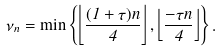<formula> <loc_0><loc_0><loc_500><loc_500>\nu _ { n } = \min \left \{ \left \lfloor \frac { ( 1 + \tau ) n } { 4 } \right \rfloor , \left \lfloor \frac { - \tau n } { 4 } \right \rfloor \right \} .</formula> 